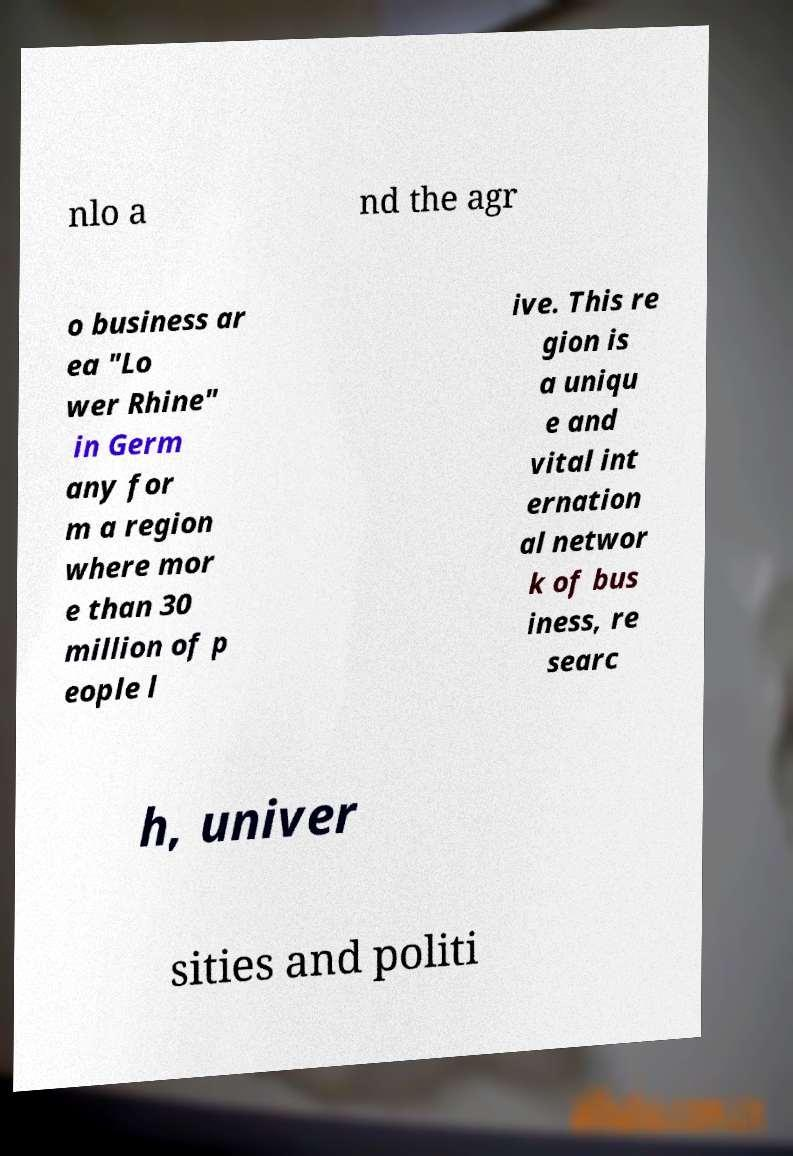For documentation purposes, I need the text within this image transcribed. Could you provide that? nlo a nd the agr o business ar ea "Lo wer Rhine" in Germ any for m a region where mor e than 30 million of p eople l ive. This re gion is a uniqu e and vital int ernation al networ k of bus iness, re searc h, univer sities and politi 